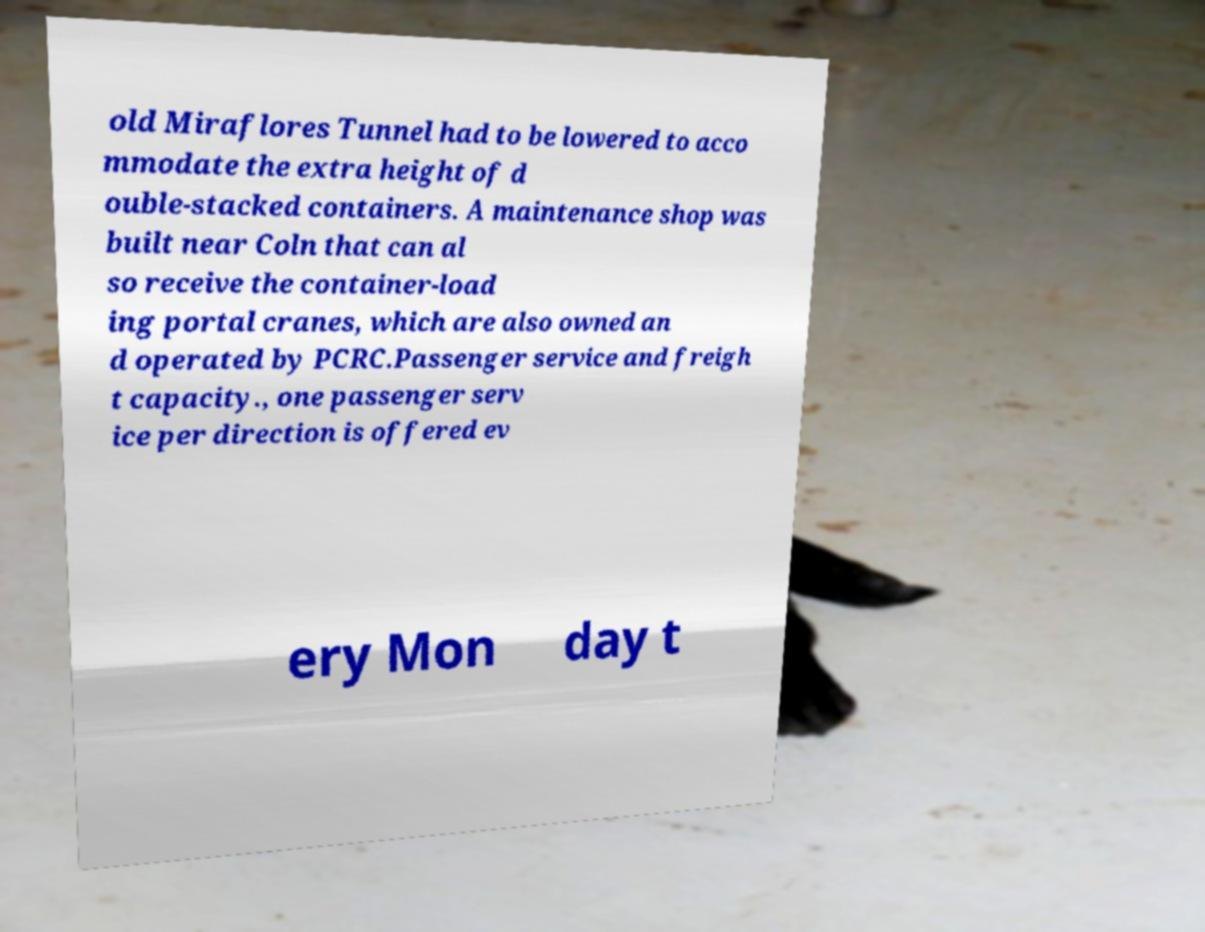What messages or text are displayed in this image? I need them in a readable, typed format. old Miraflores Tunnel had to be lowered to acco mmodate the extra height of d ouble-stacked containers. A maintenance shop was built near Coln that can al so receive the container-load ing portal cranes, which are also owned an d operated by PCRC.Passenger service and freigh t capacity., one passenger serv ice per direction is offered ev ery Mon day t 